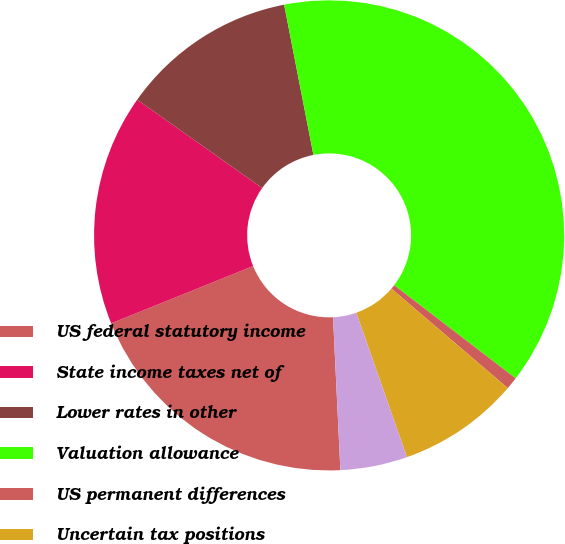Convert chart to OTSL. <chart><loc_0><loc_0><loc_500><loc_500><pie_chart><fcel>US federal statutory income<fcel>State income taxes net of<fcel>Lower rates in other<fcel>Valuation allowance<fcel>US permanent differences<fcel>Uncertain tax positions<fcel>Other net<nl><fcel>19.66%<fcel>15.9%<fcel>12.14%<fcel>38.47%<fcel>0.85%<fcel>8.37%<fcel>4.61%<nl></chart> 